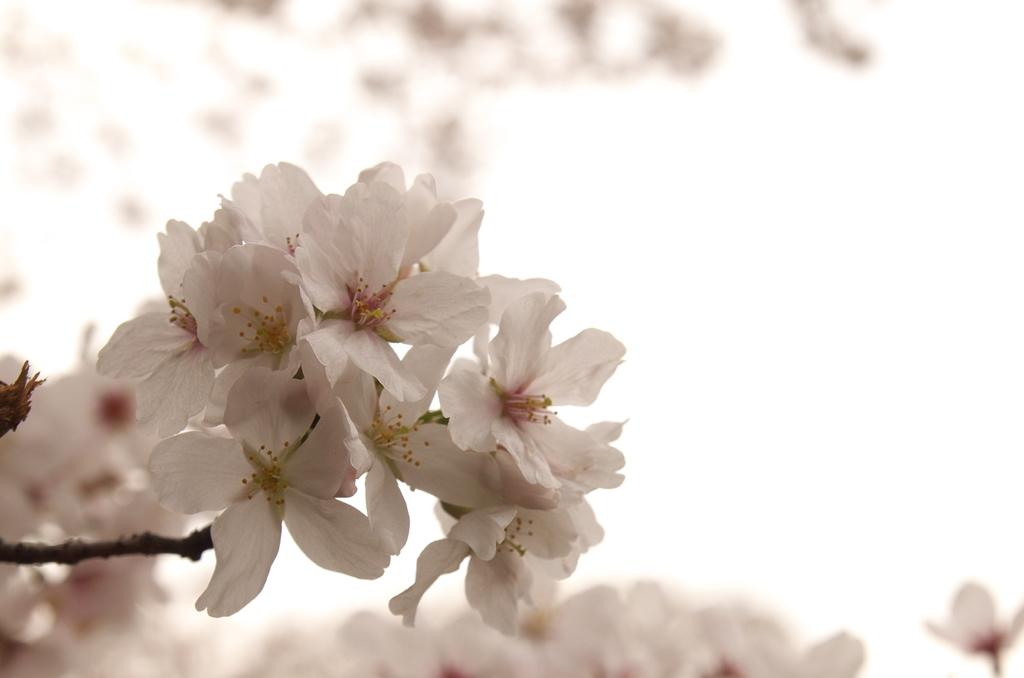What is the main subject of the image? The main subject of the image is a plant with many flowers. Can you describe the background of the image? The background of the image is blurred. How many fish can be seen swimming in the background of the image? There are no fish present in the image; the background is blurred and does not show any fish. 